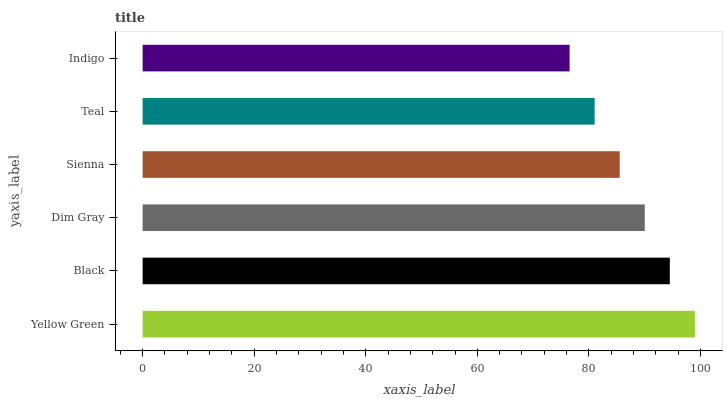Is Indigo the minimum?
Answer yes or no. Yes. Is Yellow Green the maximum?
Answer yes or no. Yes. Is Black the minimum?
Answer yes or no. No. Is Black the maximum?
Answer yes or no. No. Is Yellow Green greater than Black?
Answer yes or no. Yes. Is Black less than Yellow Green?
Answer yes or no. Yes. Is Black greater than Yellow Green?
Answer yes or no. No. Is Yellow Green less than Black?
Answer yes or no. No. Is Dim Gray the high median?
Answer yes or no. Yes. Is Sienna the low median?
Answer yes or no. Yes. Is Teal the high median?
Answer yes or no. No. Is Black the low median?
Answer yes or no. No. 